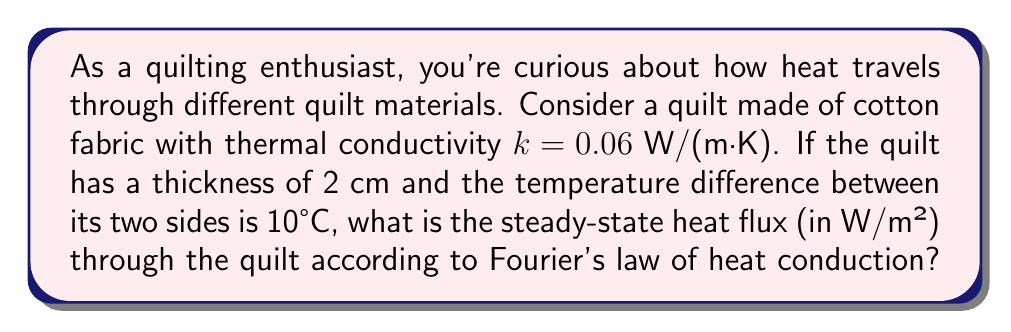What is the answer to this math problem? Let's approach this step-by-step using Fourier's law of heat conduction:

1) Fourier's law in one dimension is given by:

   $$q = -k \frac{dT}{dx}$$

   where:
   $q$ is the heat flux (W/m²)
   $k$ is the thermal conductivity (W/(m·K))
   $\frac{dT}{dx}$ is the temperature gradient (K/m)

2) In steady-state, the temperature gradient is constant:

   $$\frac{dT}{dx} = \frac{\Delta T}{\Delta x}$$

3) Given:
   - $k = 0.06 \text{ W/(m·K)}$
   - Thickness $\Delta x = 2 \text{ cm} = 0.02 \text{ m}$
   - Temperature difference $\Delta T = 10°C = 10 \text{ K}$

4) Calculate the temperature gradient:

   $$\frac{\Delta T}{\Delta x} = \frac{10 \text{ K}}{0.02 \text{ m}} = 500 \text{ K/m}$$

5) Apply Fourier's law:

   $$q = -k \frac{\Delta T}{\Delta x} = -(0.06 \text{ W/(m·K)}) \cdot (500 \text{ K/m}) = -30 \text{ W/m²}$$

6) The negative sign indicates that heat flows from higher to lower temperature. In magnitude:

   $$|q| = 30 \text{ W/m²}$$
Answer: 30 W/m² 